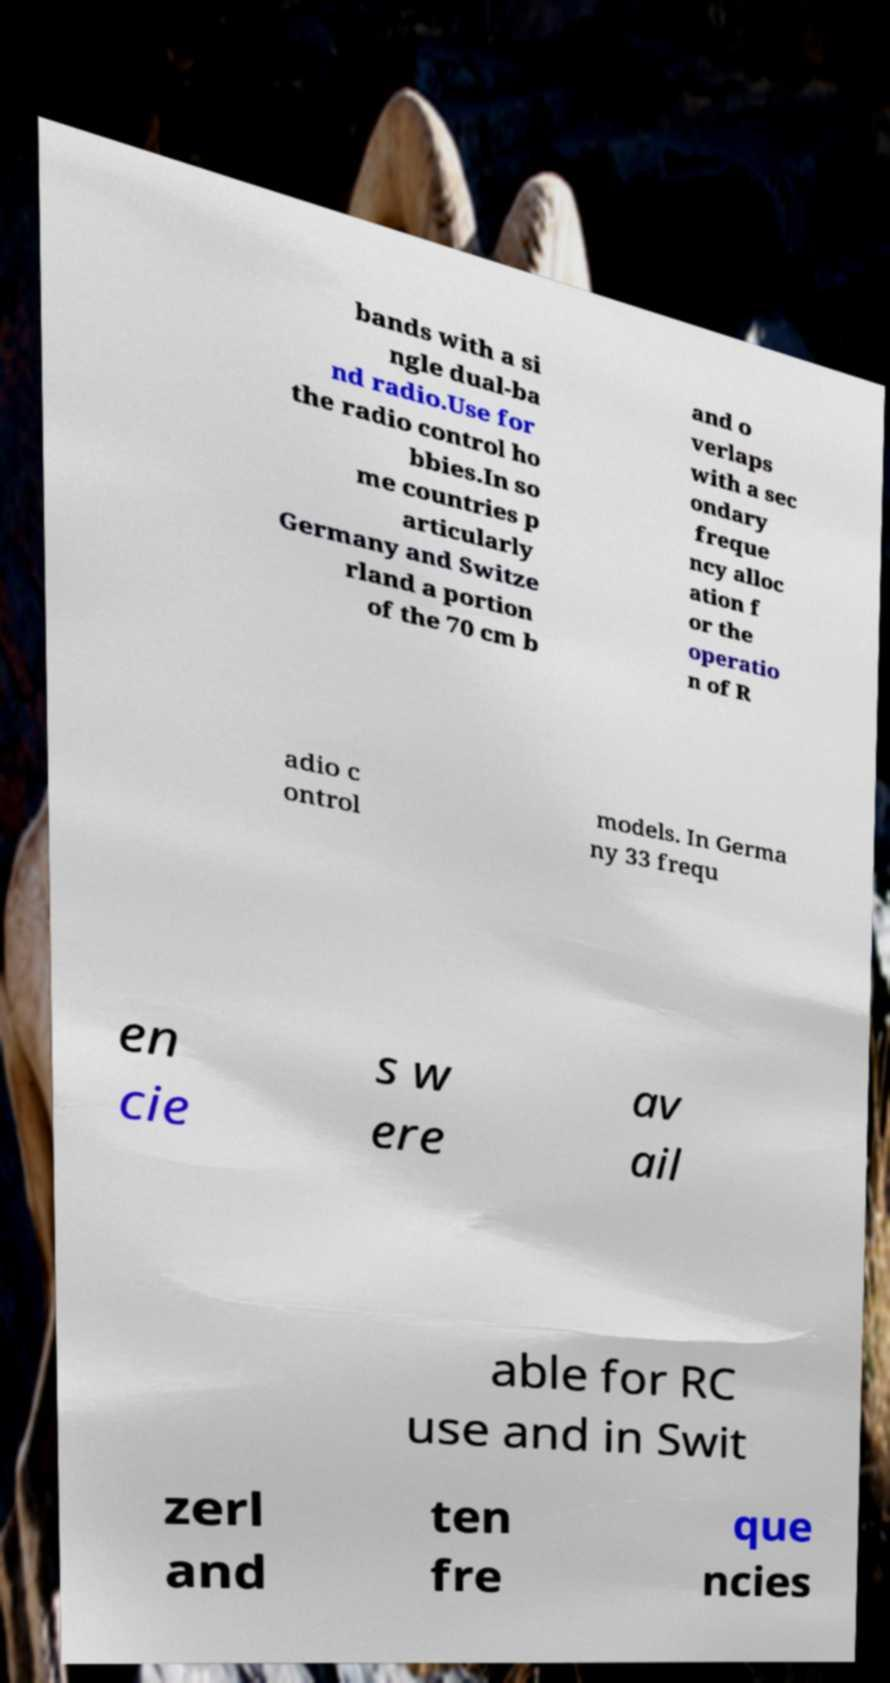Please identify and transcribe the text found in this image. bands with a si ngle dual-ba nd radio.Use for the radio control ho bbies.In so me countries p articularly Germany and Switze rland a portion of the 70 cm b and o verlaps with a sec ondary freque ncy alloc ation f or the operatio n of R adio c ontrol models. In Germa ny 33 frequ en cie s w ere av ail able for RC use and in Swit zerl and ten fre que ncies 